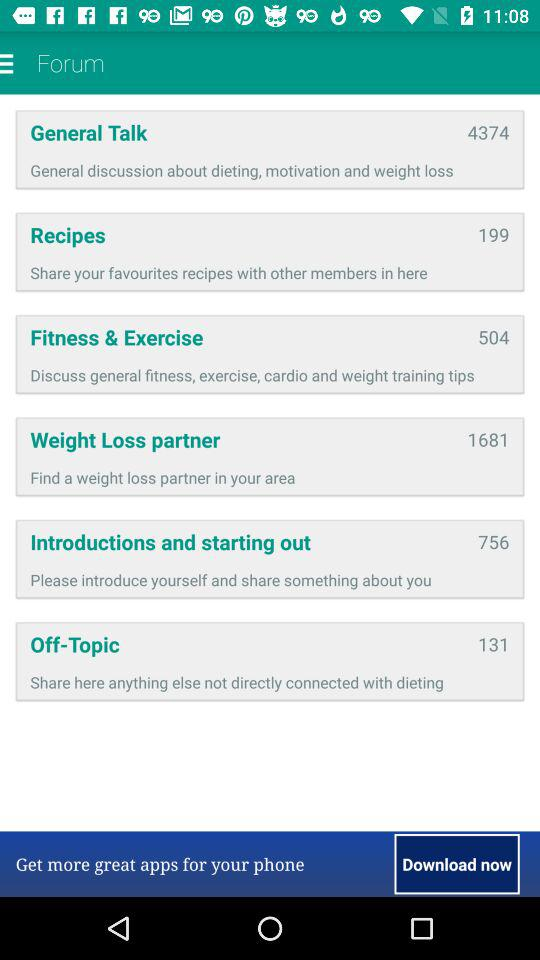What is the mentioned number of recipes? The mentioned number of recipes is 199. 